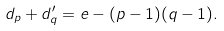Convert formula to latex. <formula><loc_0><loc_0><loc_500><loc_500>d _ { p } + d ^ { \prime } _ { q } = e - ( p - 1 ) ( q - 1 ) .</formula> 